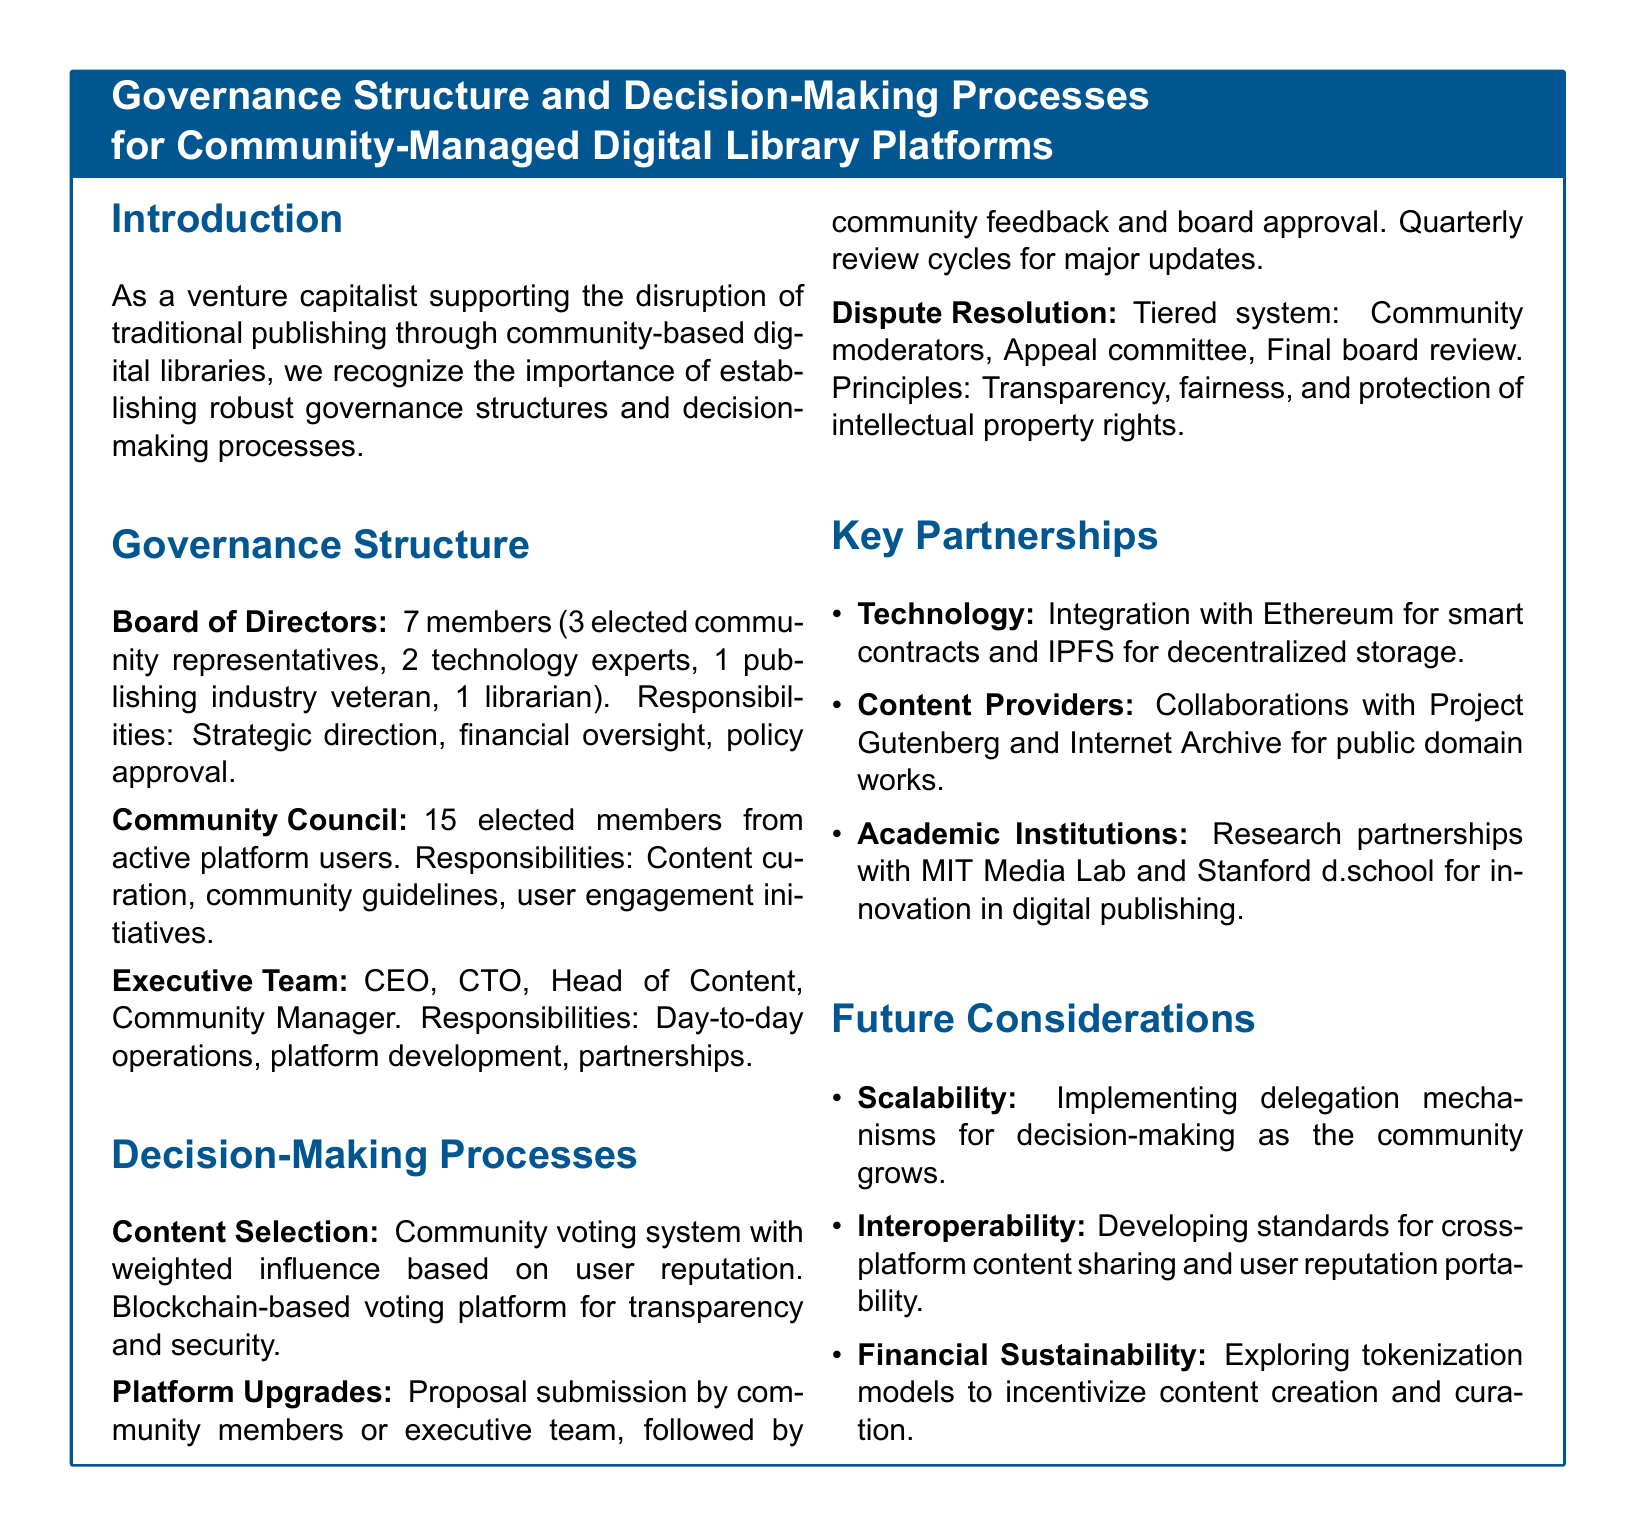What is the composition of the Board of Directors? The Board of Directors consists of 7 members, specifically 3 elected community representatives, 2 technology experts, 1 publishing industry veteran, and 1 librarian.
Answer: 7 members (3 community representatives, 2 technology experts, 1 publishing veteran, 1 librarian) What is the main responsibility of the Community Council? The main responsibility of the Community Council is content curation, community guidelines, and user engagement initiatives.
Answer: Content curation, community guidelines, user engagement initiatives How many members are in the Community Council? The Community Council is made up of 15 elected members from active platform users.
Answer: 15 members What voting system is used for content selection? The content selection process employs a community voting system that utilizes weighted influence based on user reputation and a blockchain-based voting platform.
Answer: Community voting system with weighted influence and blockchain What is the purpose of the tiered dispute resolution system? The tiered dispute resolution system aims to ensure transparency, fairness, and protection of intellectual property rights.
Answer: Transparency, fairness, protection of intellectual property rights Which technology is integrated for decentralized storage? The document mentions integration with IPFS for decentralized storage.
Answer: IPFS What type of partnerships does the document highlight under Key Partnerships? The partnerships include technology, content providers, and academic institutions for innovation in digital publishing.
Answer: Technology, content providers, academic institutions What major future consideration involves community growth? The document mentions implementing delegation mechanisms for decision-making as a future consideration related to community growth.
Answer: Delegation mechanisms How often are platform upgrades reviewed? Major updates to the platform are reviewed on a quarterly basis according to the document.
Answer: Quarterly review cycles 